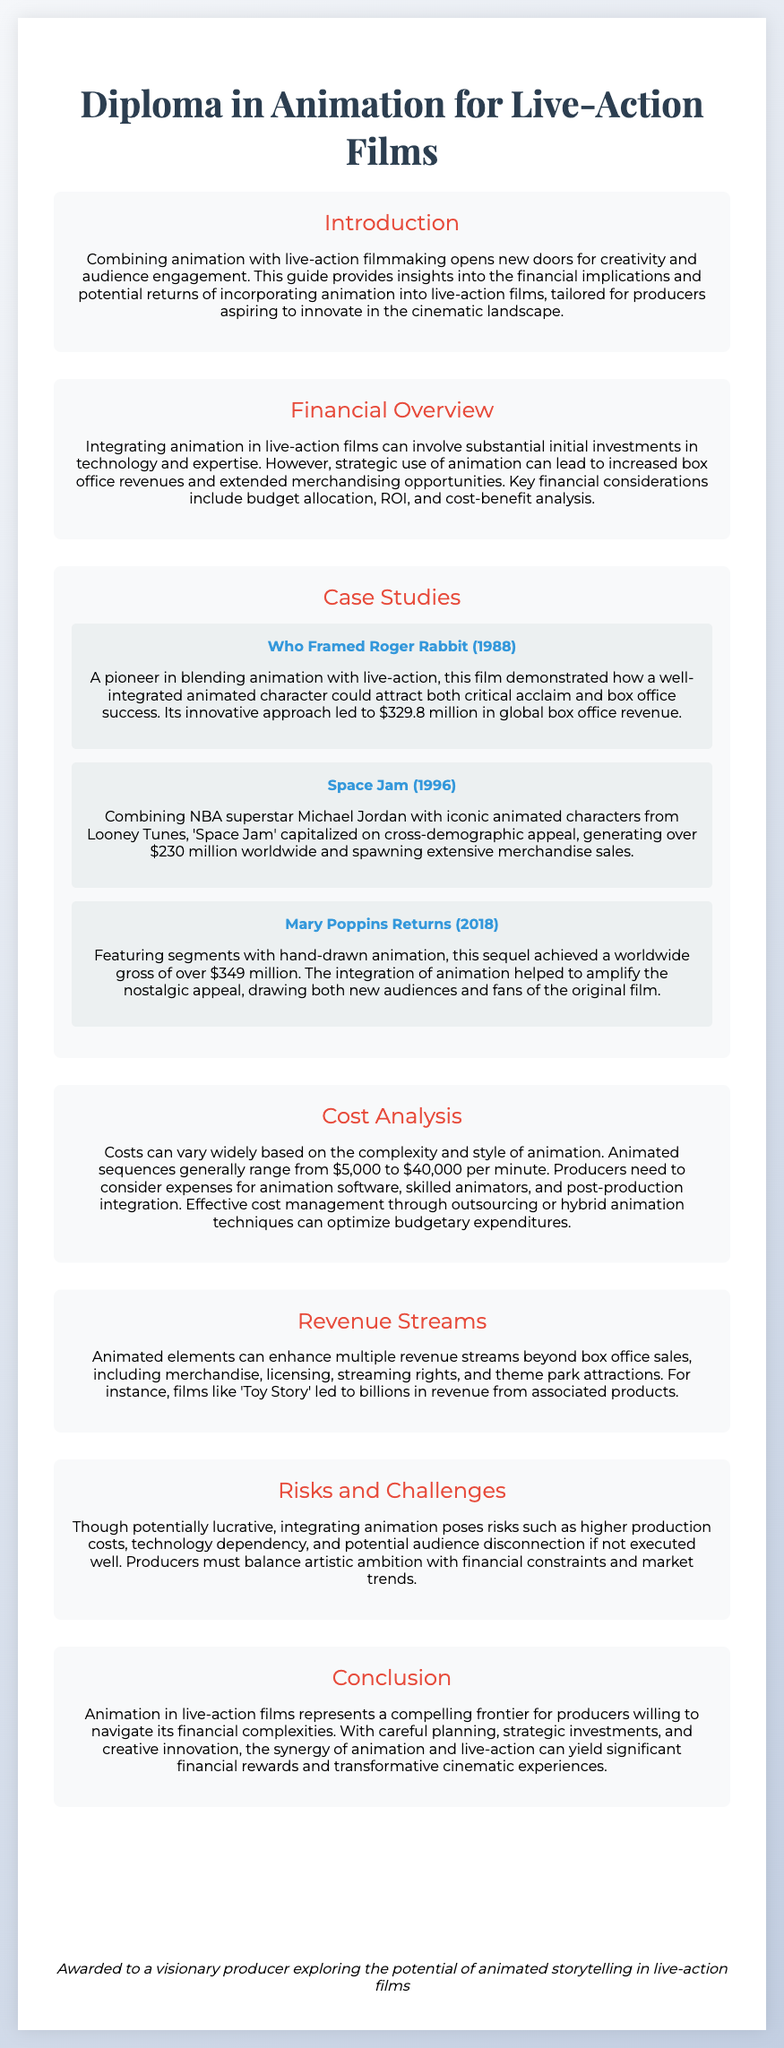what is the title of the diploma? The title of the diploma is prominently displayed at the top of the document.
Answer: Diploma in Animation for Live-Action Films what year was Who Framed Roger Rabbit released? The release year is indicated in the case study section for that film.
Answer: 1988 how much did Mary Poppins Returns gross worldwide? The worldwide gross for this film is mentioned in the case study section.
Answer: over $349 million what are the estimated costs for animation sequences per minute? The document specifies a range for animation sequence costs in the cost analysis section.
Answer: $5,000 to $40,000 which film features Michael Jordan and Looney Tunes characters? This specific film is identified in the case study section under a notable example.
Answer: Space Jam what is a key financial consideration mentioned in the overview? The financial overview highlights significant aspects that producers must consider.
Answer: budget allocation how can animated elements enhance revenue streams? The revenue streams section outlines various ways this can happen.
Answer: merchandise what is a potential risk mentioned regarding animation integration? The risks and challenges section discusses several risks associated with animation use.
Answer: higher production costs what does the seal state? The seal is a visual element that includes a certification statement.
Answer: CERTIFIED PRODUCER 